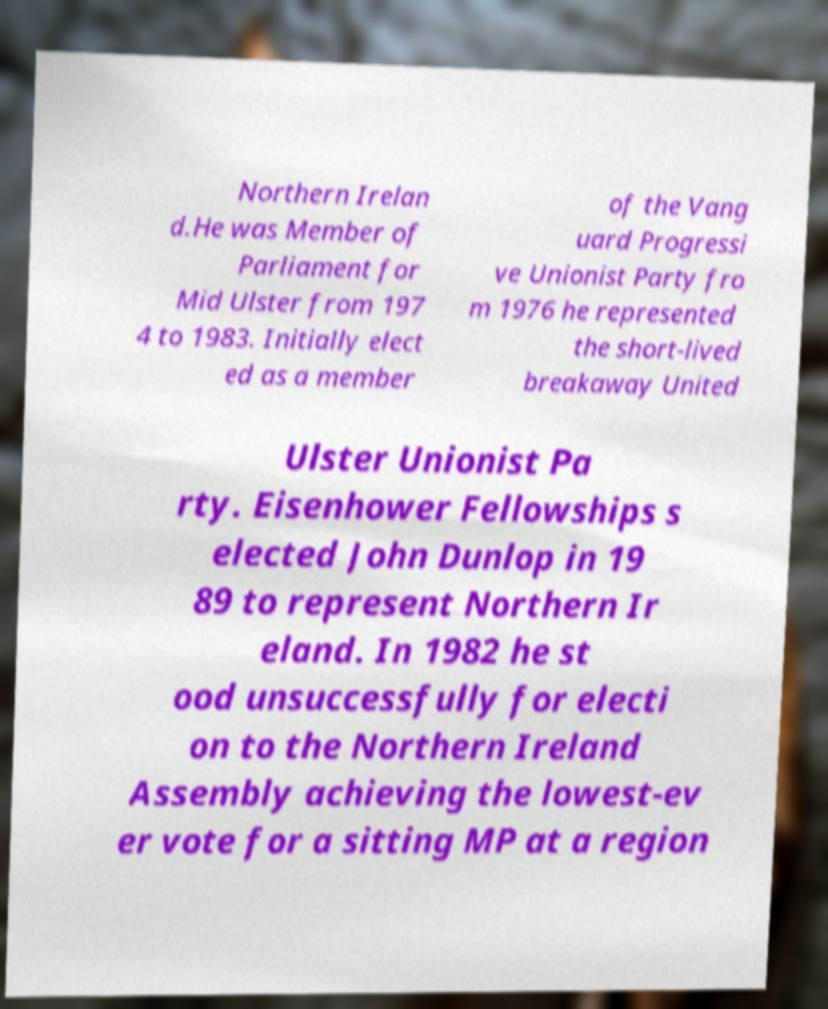Please identify and transcribe the text found in this image. Northern Irelan d.He was Member of Parliament for Mid Ulster from 197 4 to 1983. Initially elect ed as a member of the Vang uard Progressi ve Unionist Party fro m 1976 he represented the short-lived breakaway United Ulster Unionist Pa rty. Eisenhower Fellowships s elected John Dunlop in 19 89 to represent Northern Ir eland. In 1982 he st ood unsuccessfully for electi on to the Northern Ireland Assembly achieving the lowest-ev er vote for a sitting MP at a region 